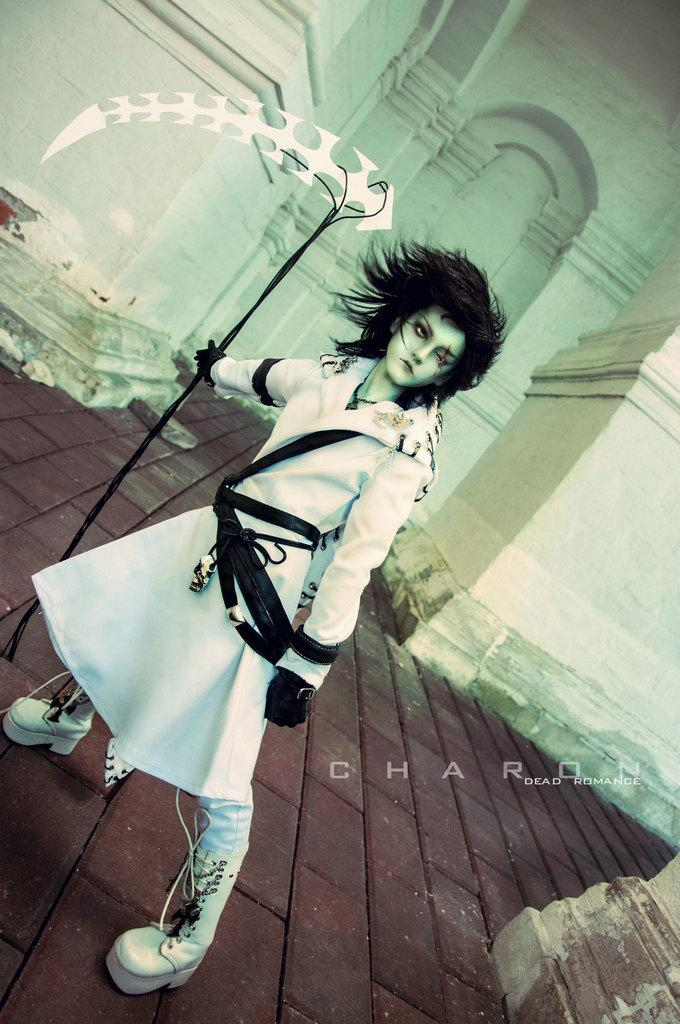What is the person in the image holding? The person is holding an object in the image. What type of image is this? The image is an animated image. What can be seen beneath the person's feet? There is ground visible in the image. What is located behind the person? There is a wall in the image. What is present in the bottom right corner of the image? There is an object in the bottom right corner of the image. Are there any words or letters in the image? Yes, there is text present in the image. What type of ornament is hanging from the steam in the image? There is no steam or ornament present in the image. 